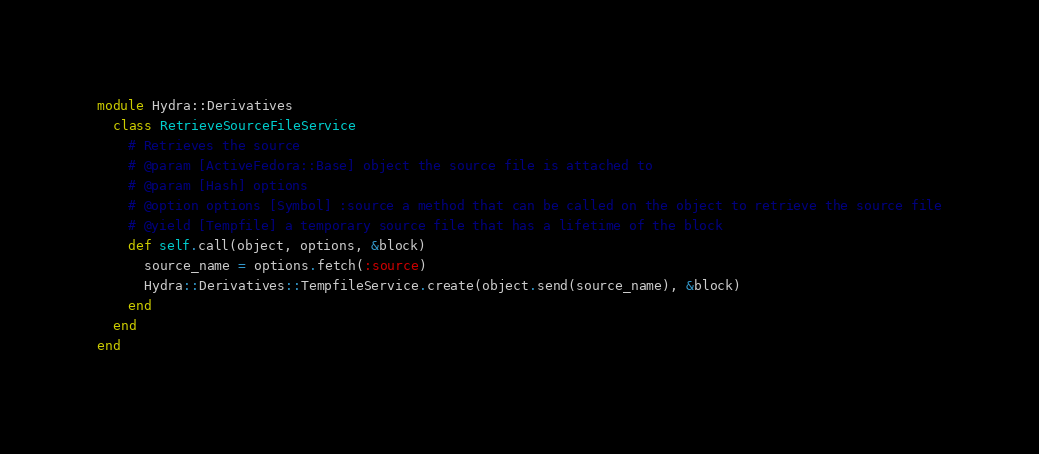<code> <loc_0><loc_0><loc_500><loc_500><_Ruby_>module Hydra::Derivatives
  class RetrieveSourceFileService
    # Retrieves the source
    # @param [ActiveFedora::Base] object the source file is attached to
    # @param [Hash] options
    # @option options [Symbol] :source a method that can be called on the object to retrieve the source file
    # @yield [Tempfile] a temporary source file that has a lifetime of the block
    def self.call(object, options, &block)
      source_name = options.fetch(:source)
      Hydra::Derivatives::TempfileService.create(object.send(source_name), &block)
    end
  end
end
</code> 